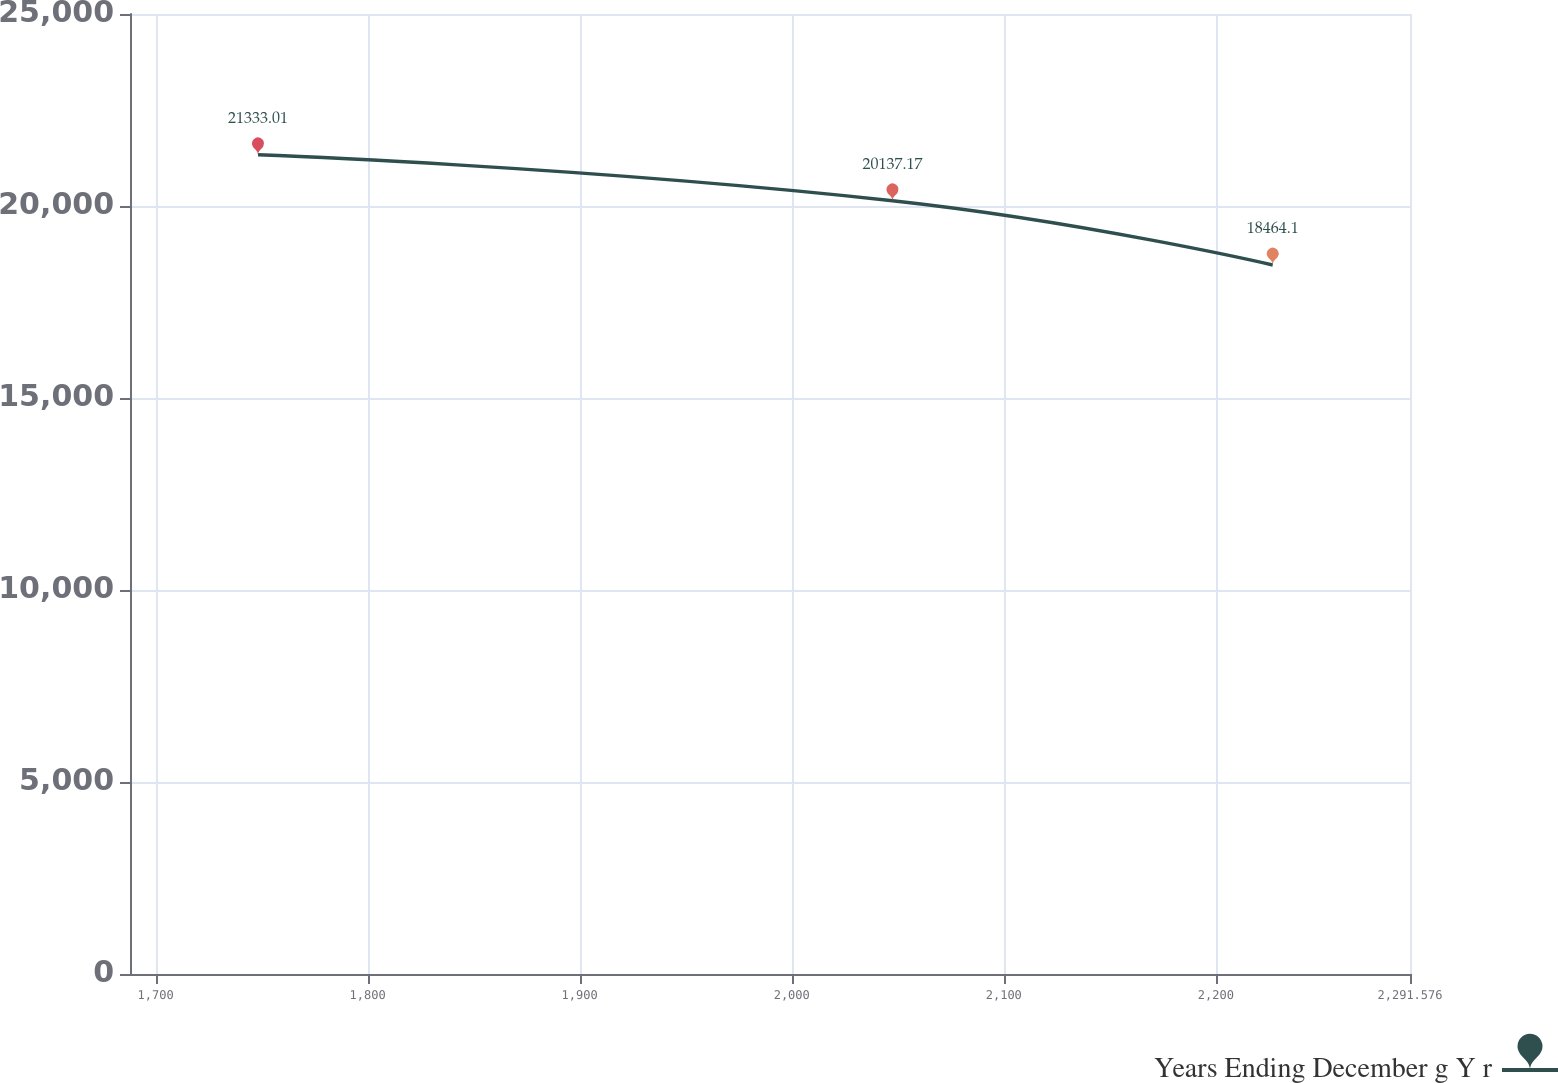Convert chart to OTSL. <chart><loc_0><loc_0><loc_500><loc_500><line_chart><ecel><fcel>Years Ending December g Y r<nl><fcel>1748.3<fcel>21333<nl><fcel>2047.52<fcel>20137.2<nl><fcel>2226.84<fcel>18464.1<nl><fcel>2351.94<fcel>8238.58<nl></chart> 